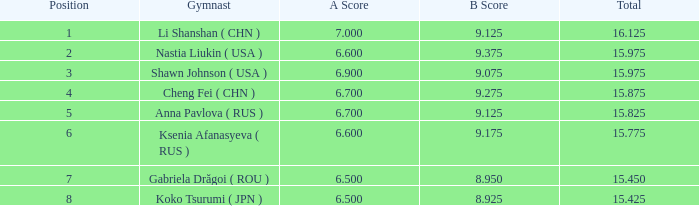Can you parse all the data within this table? {'header': ['Position', 'Gymnast', 'A Score', 'B Score', 'Total'], 'rows': [['1', 'Li Shanshan ( CHN )', '7.000', '9.125', '16.125'], ['2', 'Nastia Liukin ( USA )', '6.600', '9.375', '15.975'], ['3', 'Shawn Johnson ( USA )', '6.900', '9.075', '15.975'], ['4', 'Cheng Fei ( CHN )', '6.700', '9.275', '15.875'], ['5', 'Anna Pavlova ( RUS )', '6.700', '9.125', '15.825'], ['6', 'Ksenia Afanasyeva ( RUS )', '6.600', '9.175', '15.775'], ['7', 'Gabriela Drăgoi ( ROU )', '6.500', '8.950', '15.450'], ['8', 'Koko Tsurumi ( JPN )', '6.500', '8.925', '15.425']]} What the B Score when the total is 16.125 and the position is less than 7? 9.125. 